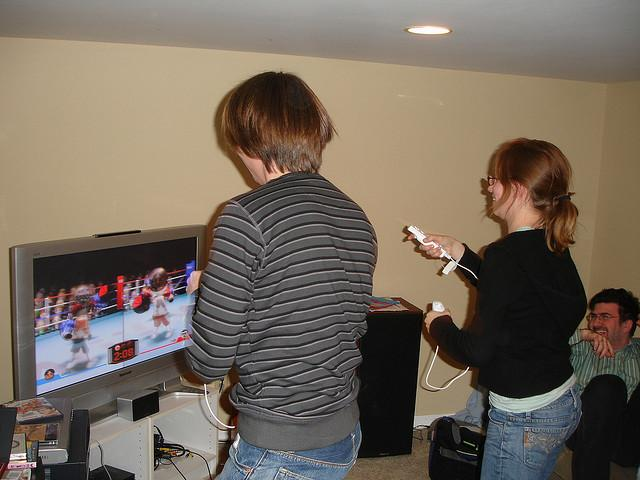What color shirt does the person opposing the wii woman in black? gray 